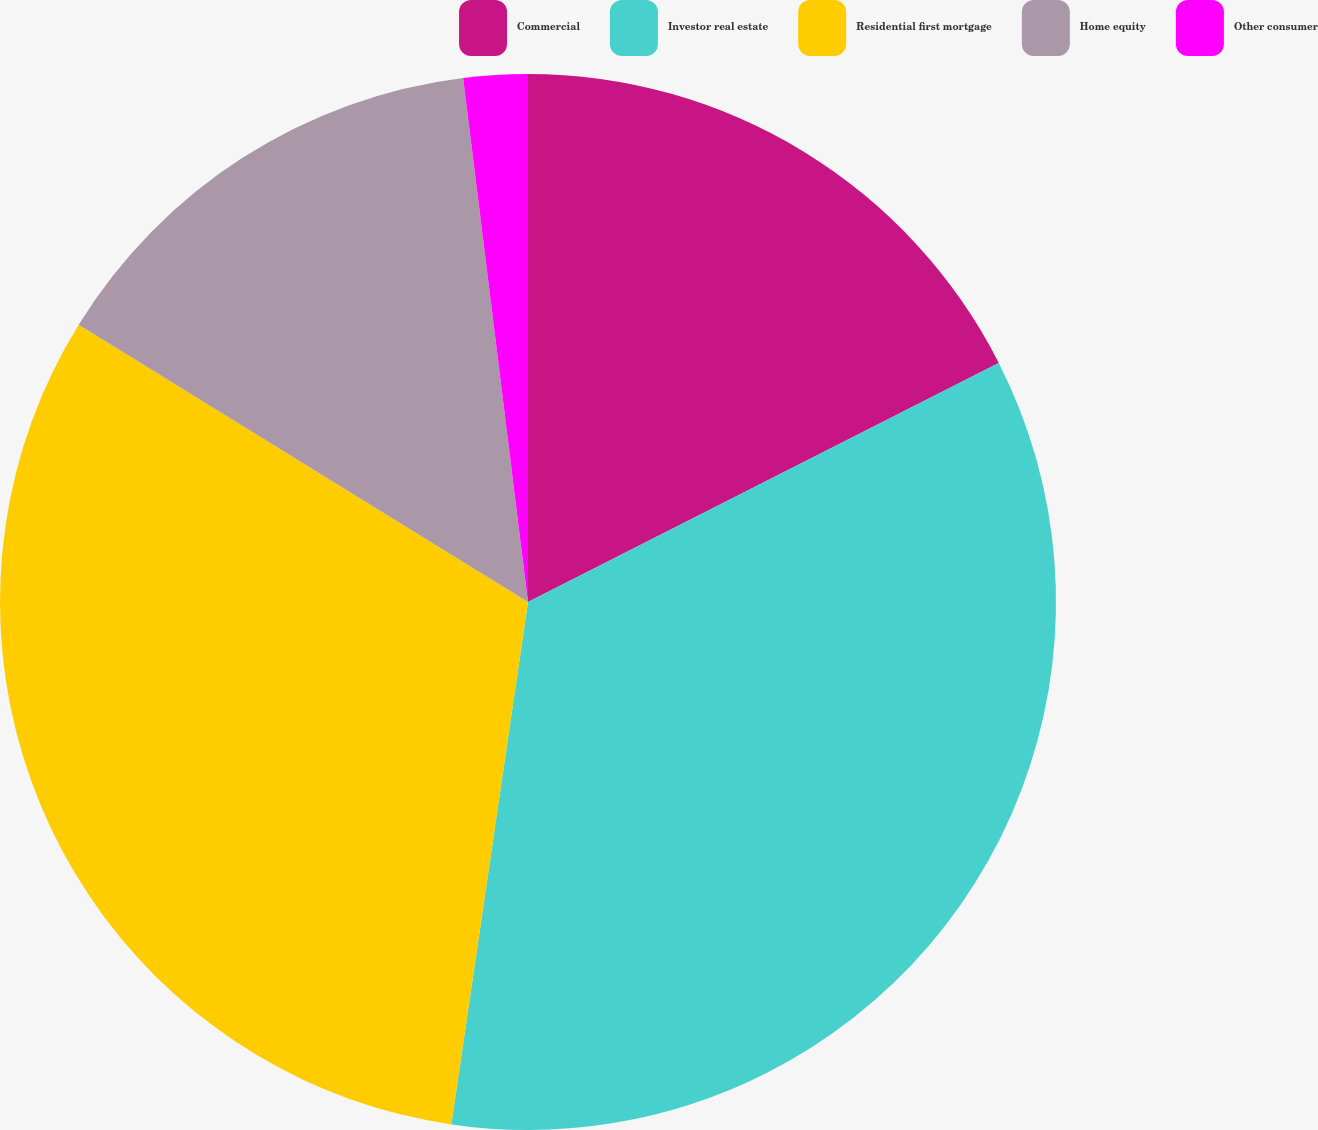Convert chart to OTSL. <chart><loc_0><loc_0><loc_500><loc_500><pie_chart><fcel>Commercial<fcel>Investor real estate<fcel>Residential first mortgage<fcel>Home equity<fcel>Other consumer<nl><fcel>17.52%<fcel>34.8%<fcel>31.48%<fcel>14.24%<fcel>1.96%<nl></chart> 